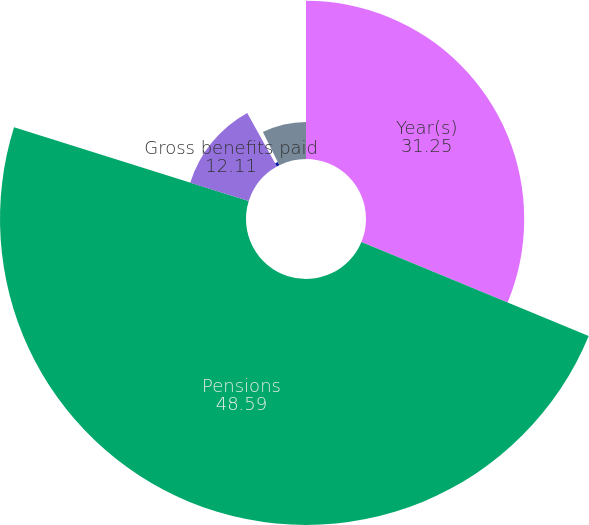Convert chart to OTSL. <chart><loc_0><loc_0><loc_500><loc_500><pie_chart><fcel>Year(s)<fcel>Pensions<fcel>Gross benefits paid<fcel>Medicare Part D and other<fcel>Net other postretirement<nl><fcel>31.25%<fcel>48.59%<fcel>12.11%<fcel>0.73%<fcel>7.32%<nl></chart> 